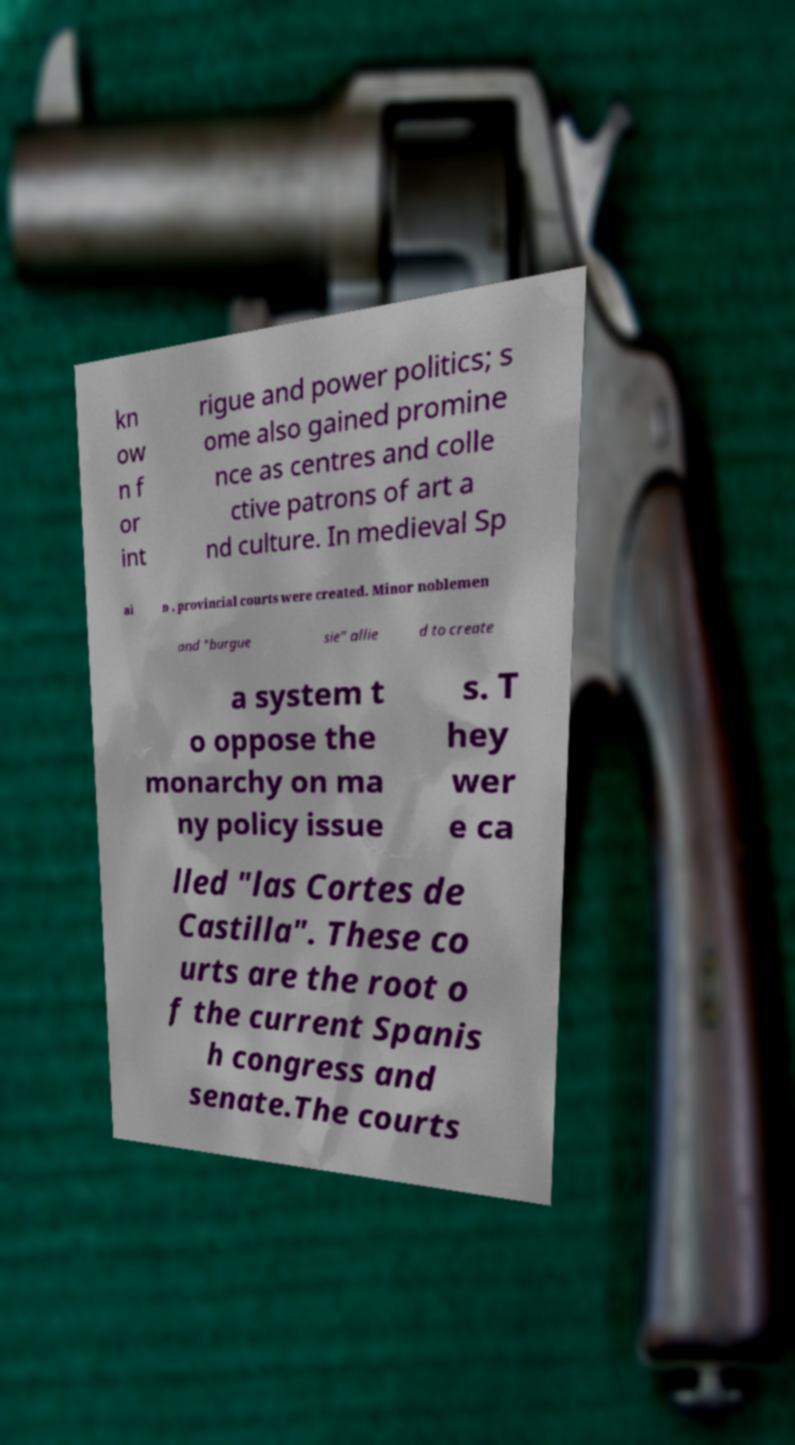Can you accurately transcribe the text from the provided image for me? kn ow n f or int rigue and power politics; s ome also gained promine nce as centres and colle ctive patrons of art a nd culture. In medieval Sp ai n , provincial courts were created. Minor noblemen and "burgue sie" allie d to create a system t o oppose the monarchy on ma ny policy issue s. T hey wer e ca lled "las Cortes de Castilla". These co urts are the root o f the current Spanis h congress and senate.The courts 